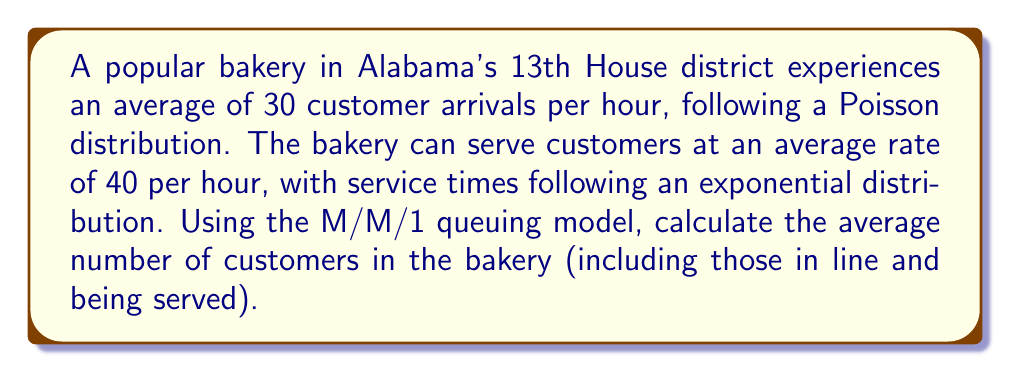Provide a solution to this math problem. To solve this problem, we'll use the M/M/1 queuing model, which is appropriate for a single-server system with Poisson arrivals and exponential service times. Let's follow these steps:

1. Define the variables:
   $\lambda$ = arrival rate = 30 customers/hour
   $\mu$ = service rate = 40 customers/hour

2. Calculate the utilization factor $\rho$:
   $$\rho = \frac{\lambda}{\mu} = \frac{30}{40} = 0.75$$

3. Use the formula for the average number of customers in the system (L):
   $$L = \frac{\rho}{1 - \rho}$$

4. Substitute the calculated $\rho$ value:
   $$L = \frac{0.75}{1 - 0.75} = \frac{0.75}{0.25} = 3$$

Therefore, the average number of customers in the bakery, including those in line and being served, is 3.
Answer: 3 customers 